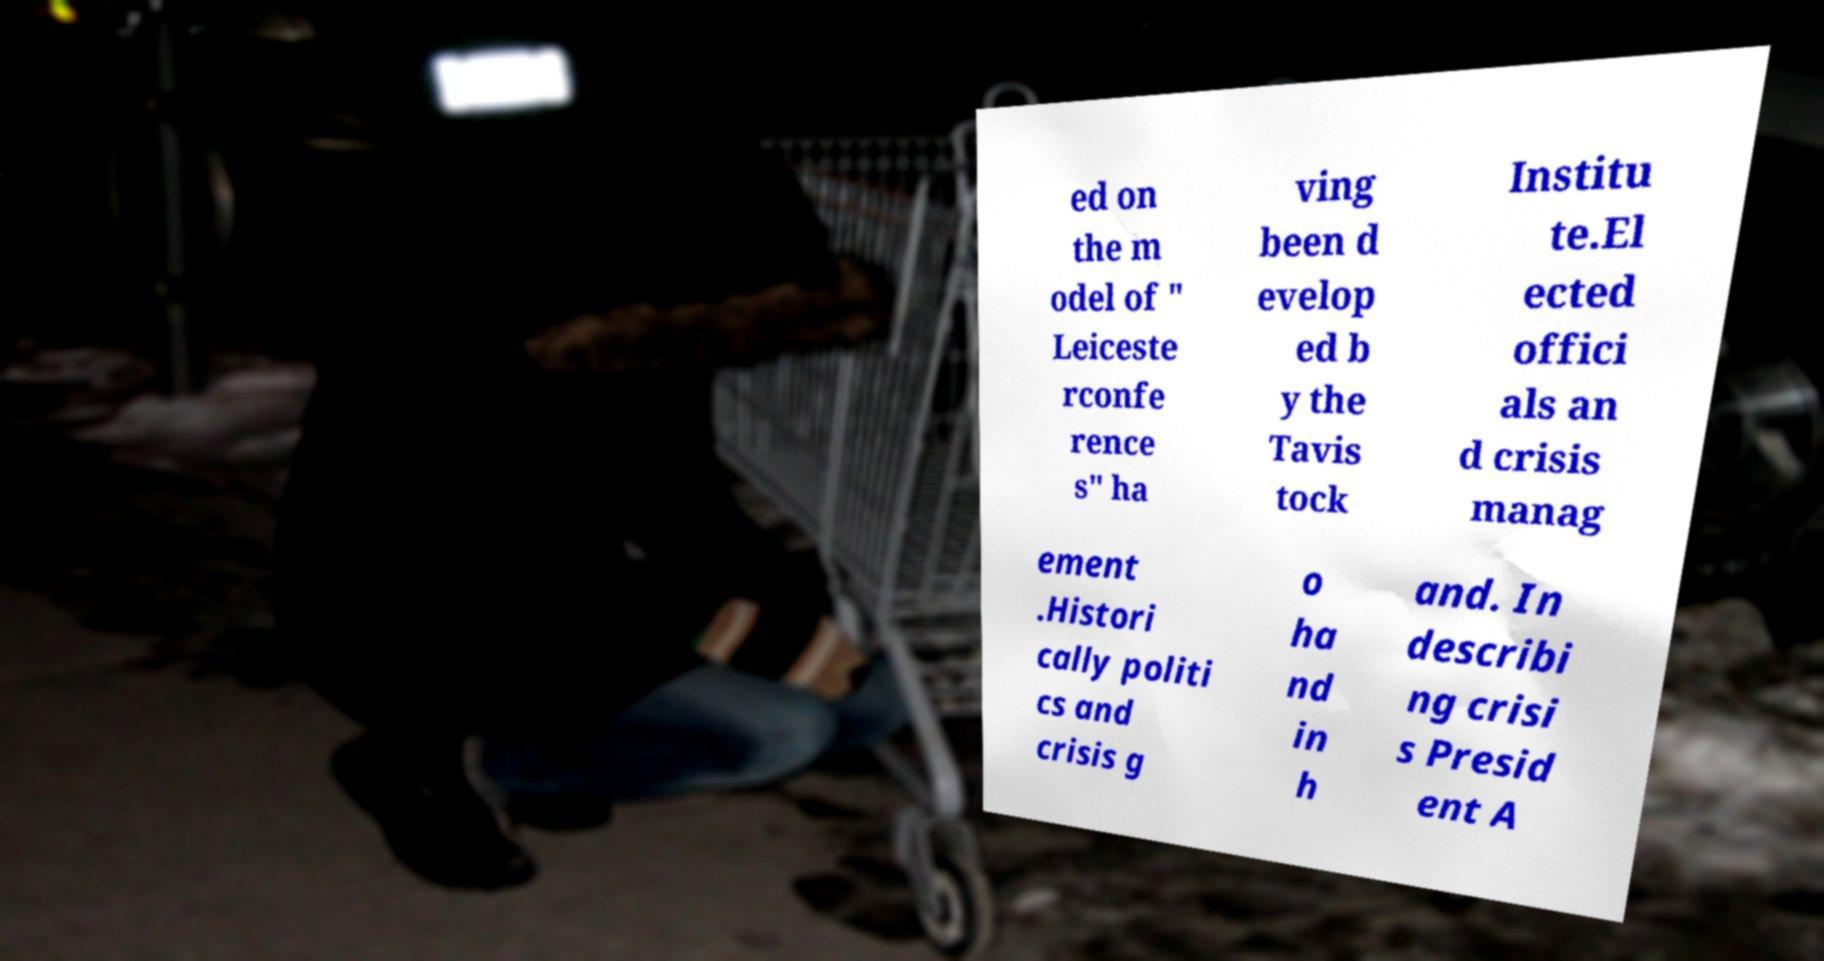For documentation purposes, I need the text within this image transcribed. Could you provide that? ed on the m odel of " Leiceste rconfe rence s" ha ving been d evelop ed b y the Tavis tock Institu te.El ected offici als an d crisis manag ement .Histori cally politi cs and crisis g o ha nd in h and. In describi ng crisi s Presid ent A 